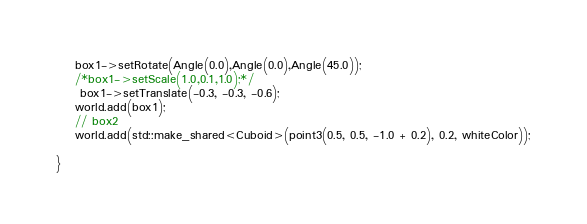<code> <loc_0><loc_0><loc_500><loc_500><_C++_>	box1->setRotate(Angle(0.0),Angle(0.0),Angle(45.0));
	/*box1->setScale(1.0,0.1,1.0);*/
	 box1->setTranslate(-0.3, -0.3, -0.6);
	world.add(box1);
	// box2
	world.add(std::make_shared<Cuboid>(point3(0.5, 0.5, -1.0 + 0.2), 0.2, whiteColor));

}
</code> 